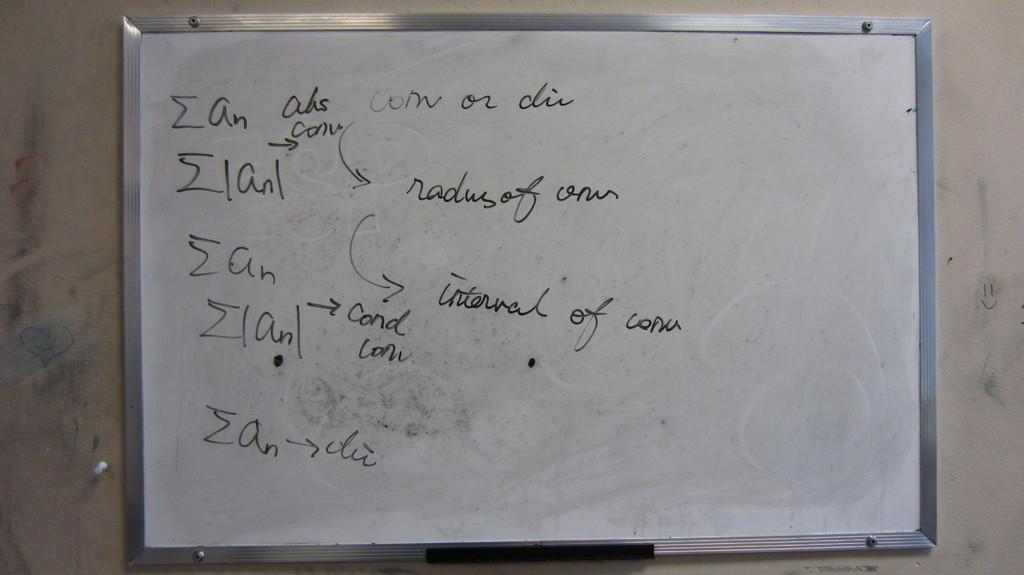What is the main object in the image? There is a whiteboard in the image. What is written or drawn on the whiteboard? There is text on the whiteboard. What can be seen behind the whiteboard in the image? There is a wall in the background of the image. How many pies are displayed on the whiteboard in the image? There are no pies present on the whiteboard in the image. What design elements can be seen on the wall in the image? The provided facts do not mention any design elements on the wall; only the presence of a wall is mentioned. 